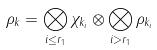Convert formula to latex. <formula><loc_0><loc_0><loc_500><loc_500>\rho _ { k } = \bigotimes _ { i \leq r _ { 1 } } \chi _ { k _ { i } } \otimes \bigotimes _ { i > r _ { 1 } } \rho _ { k _ { i } }</formula> 